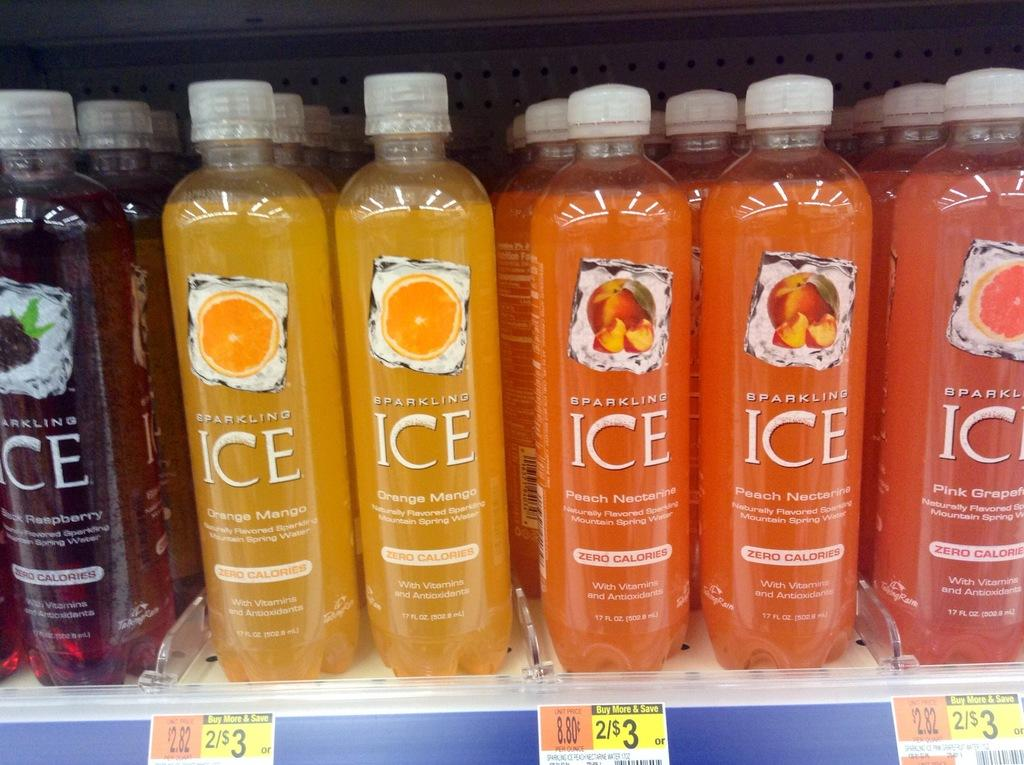<image>
Share a concise interpretation of the image provided. Several bottles of ICE sparking water sit on display in the store 